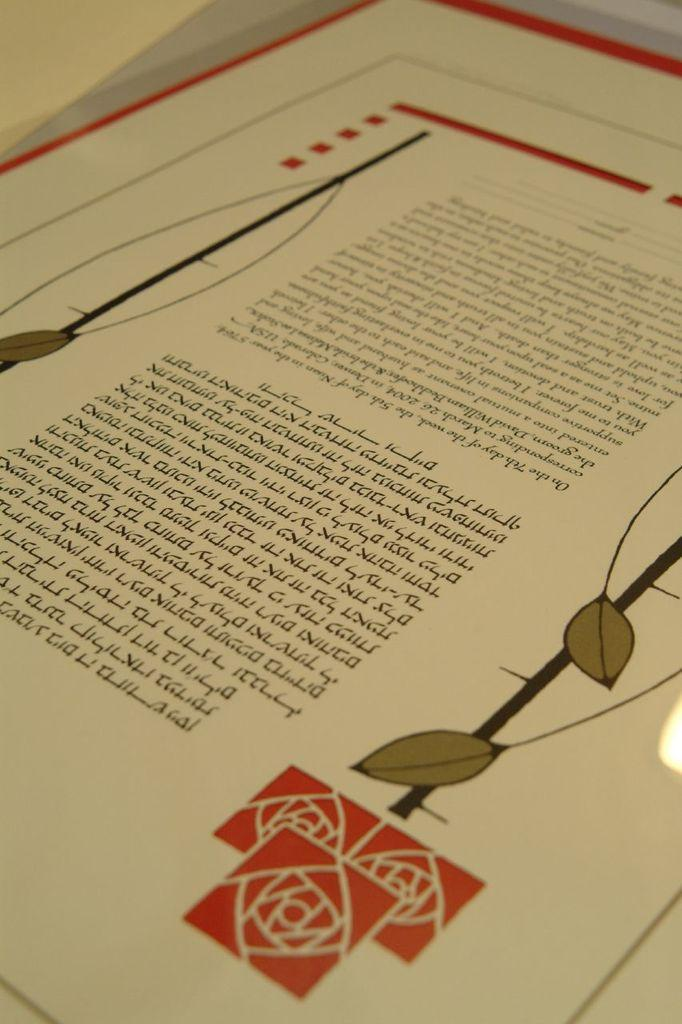What is present on the paper in the image? There is a paper in the image, and it has text on it. Can you describe the content of the paper? The paper has two pictures on it. How are the bells transported in the image? There are no bells present in the image. Who is the creator of the paper in the image? The facts provided do not give information about the creator of the paper. 